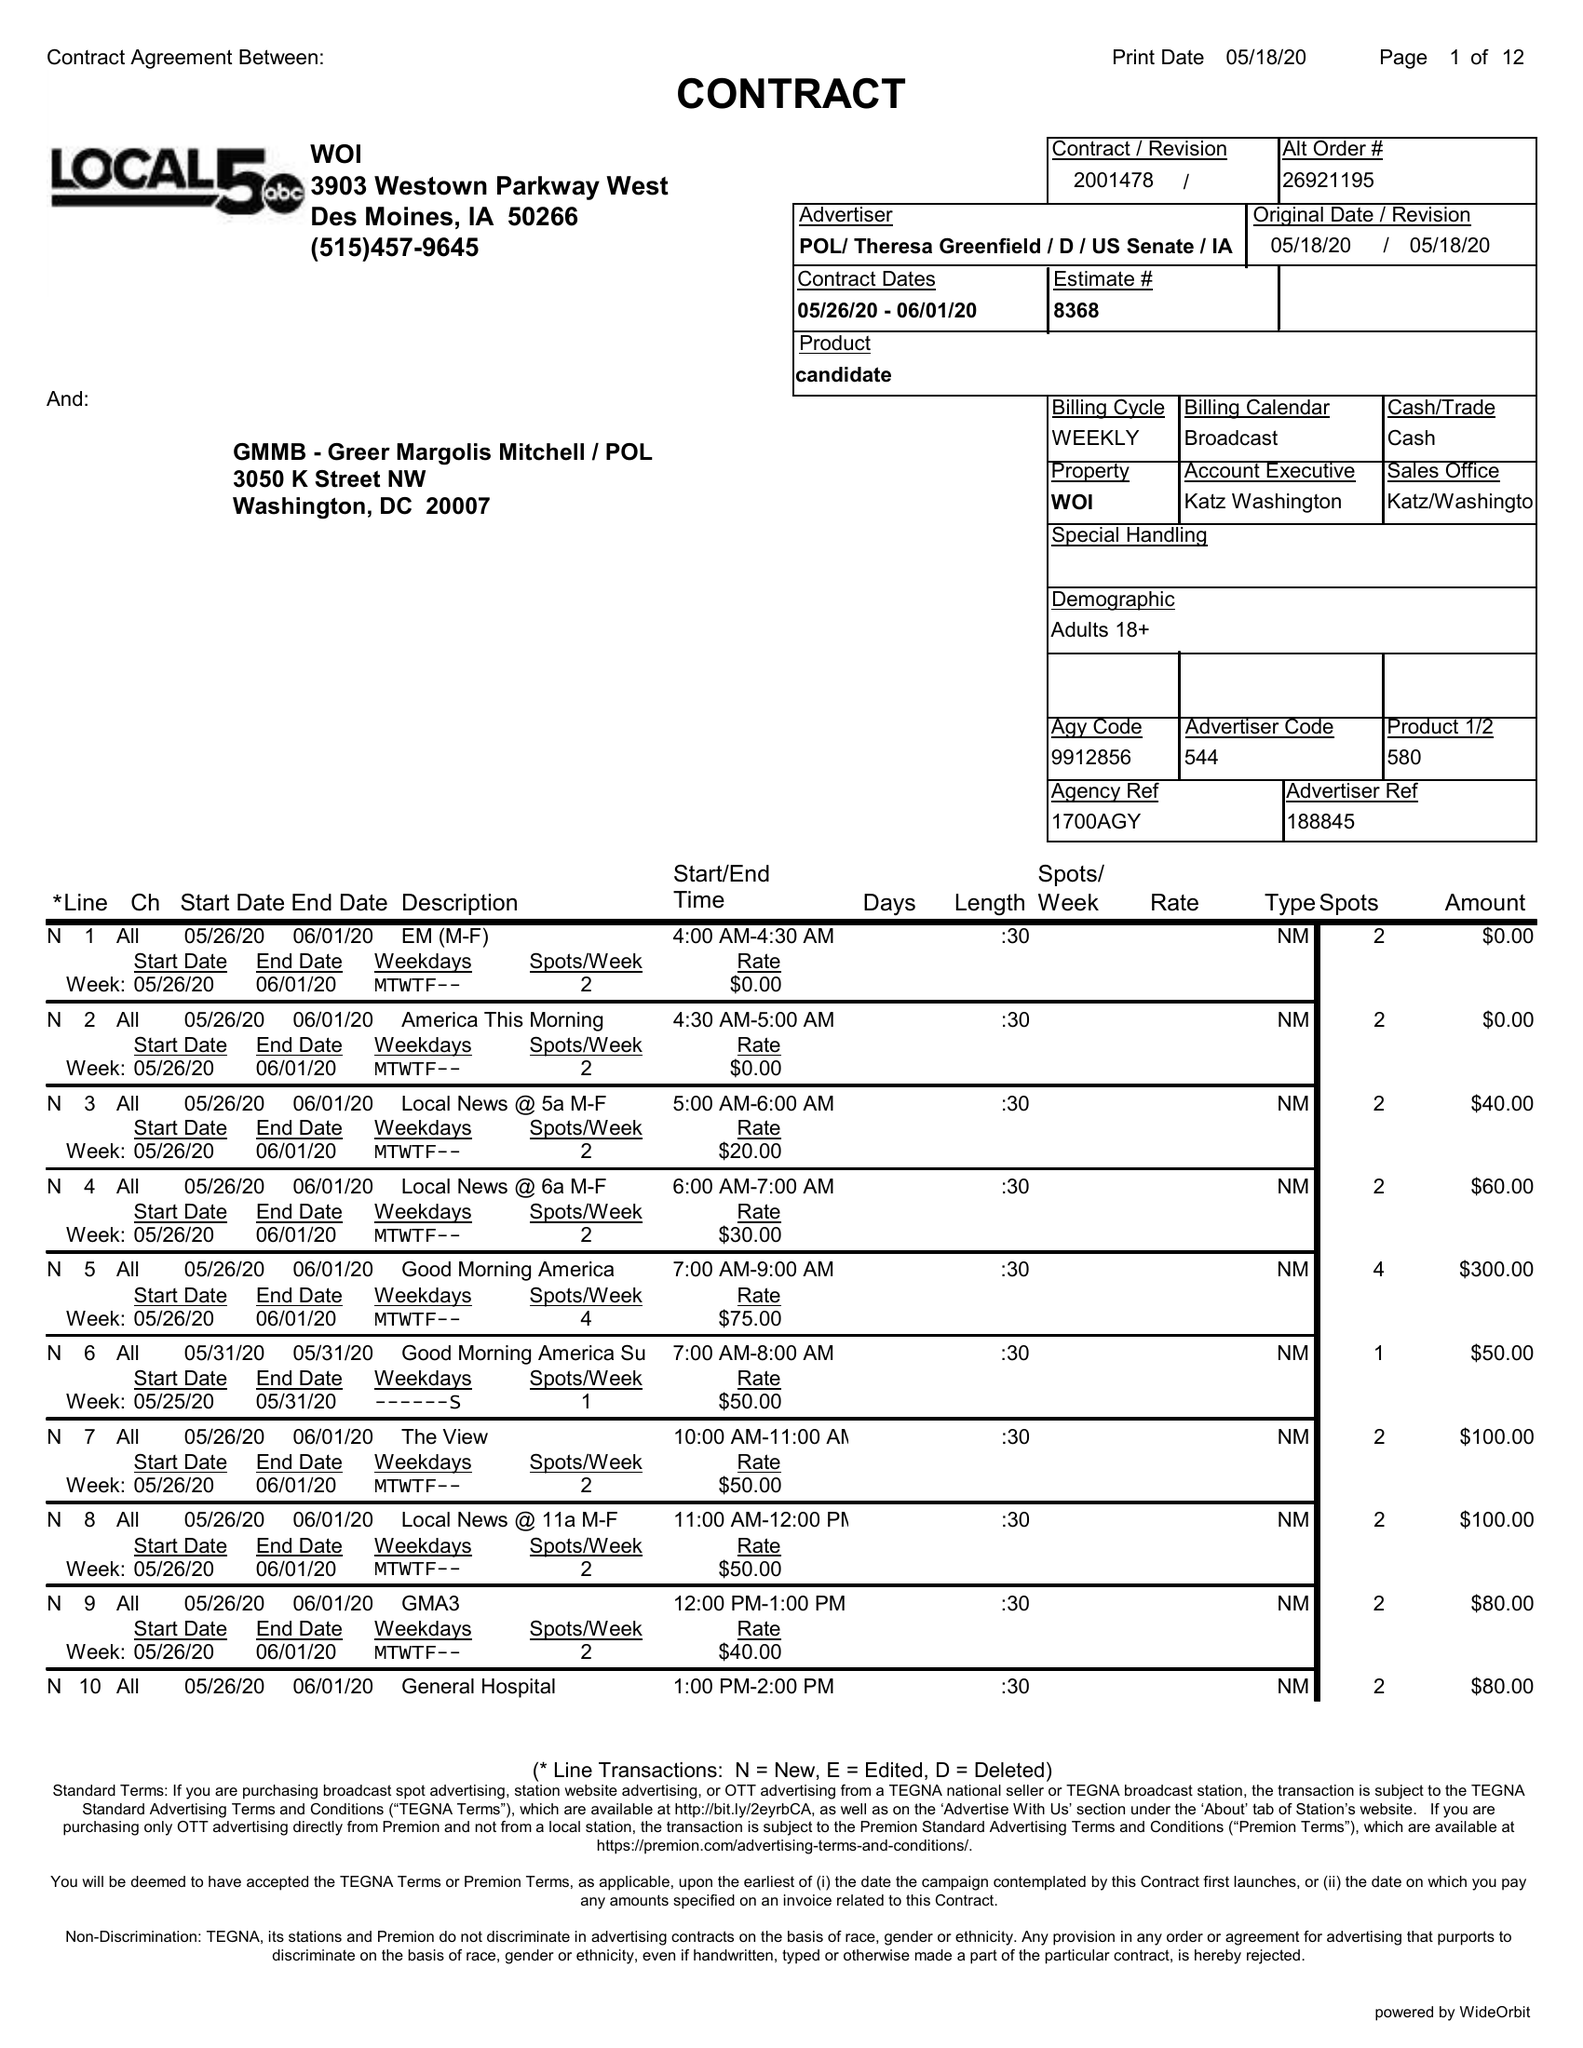What is the value for the flight_to?
Answer the question using a single word or phrase. 06/01/20 